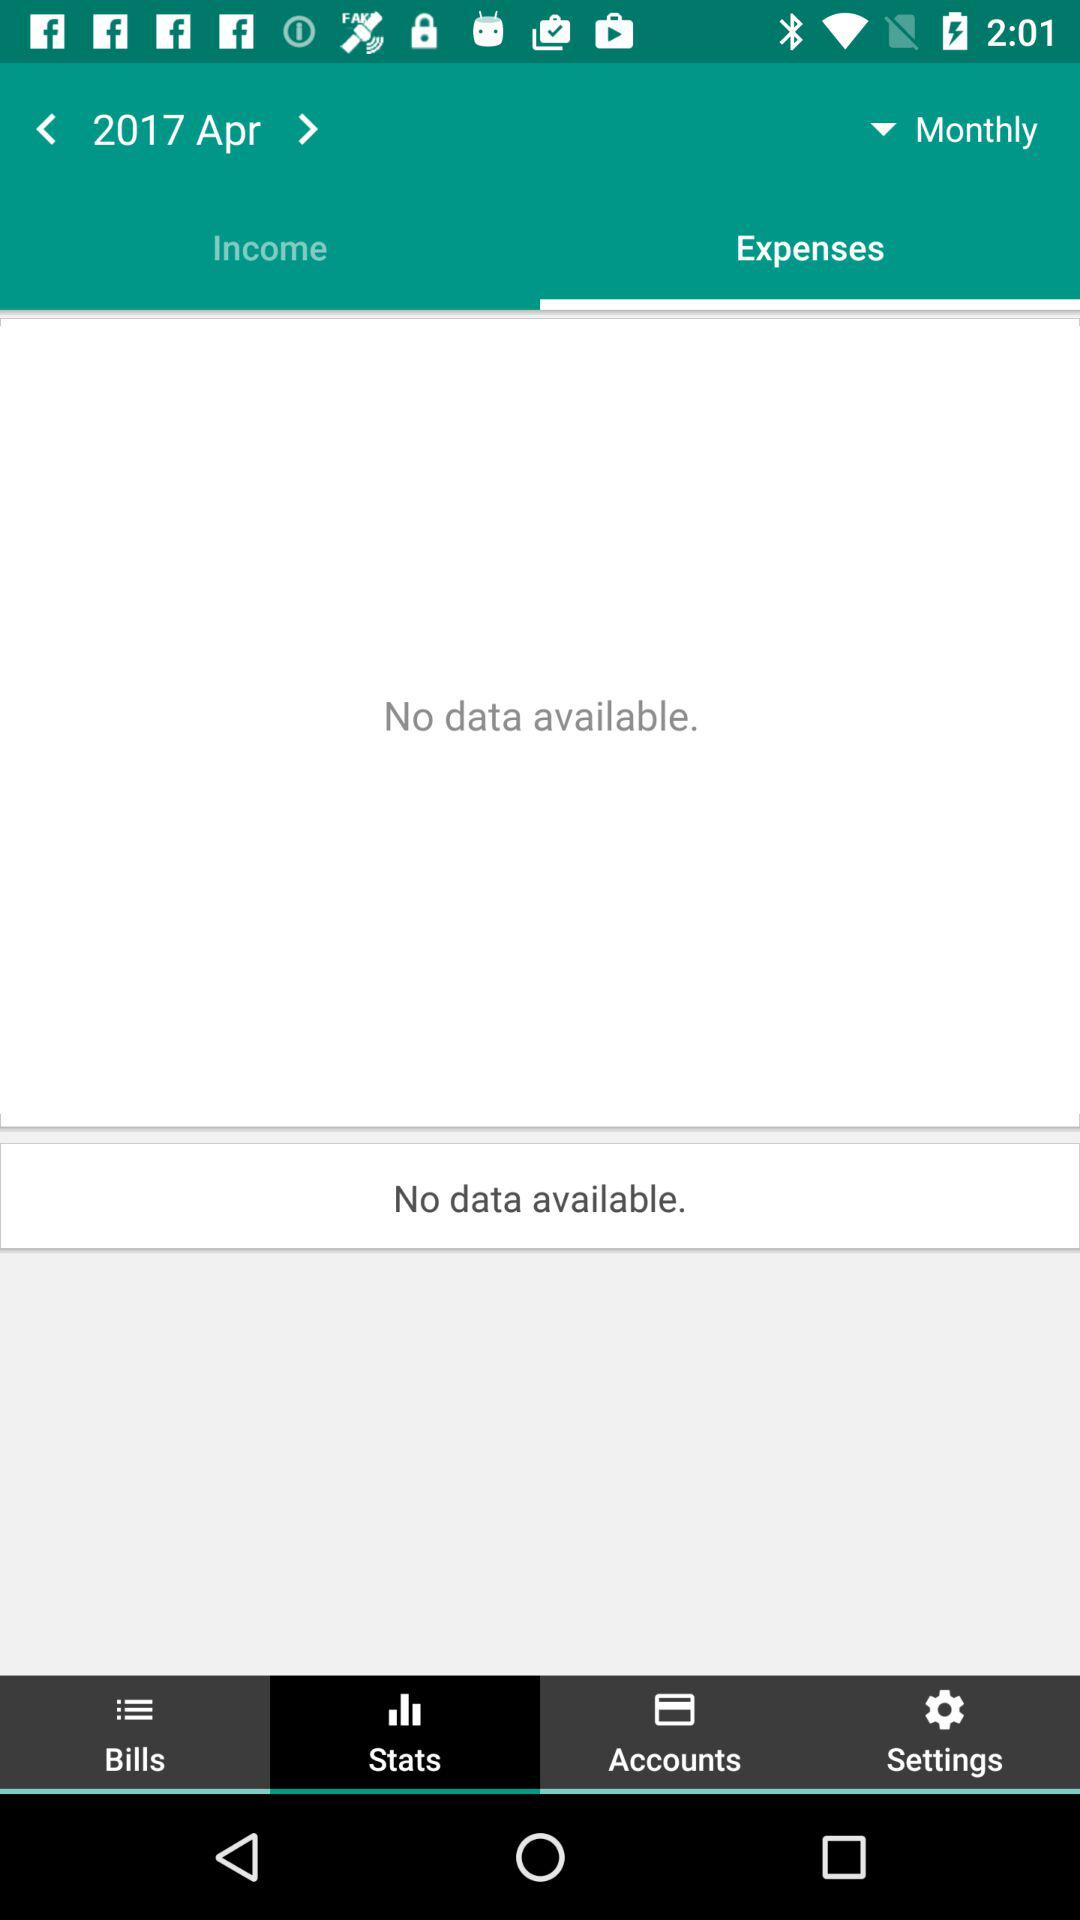Is there any data available? There is no data available. 